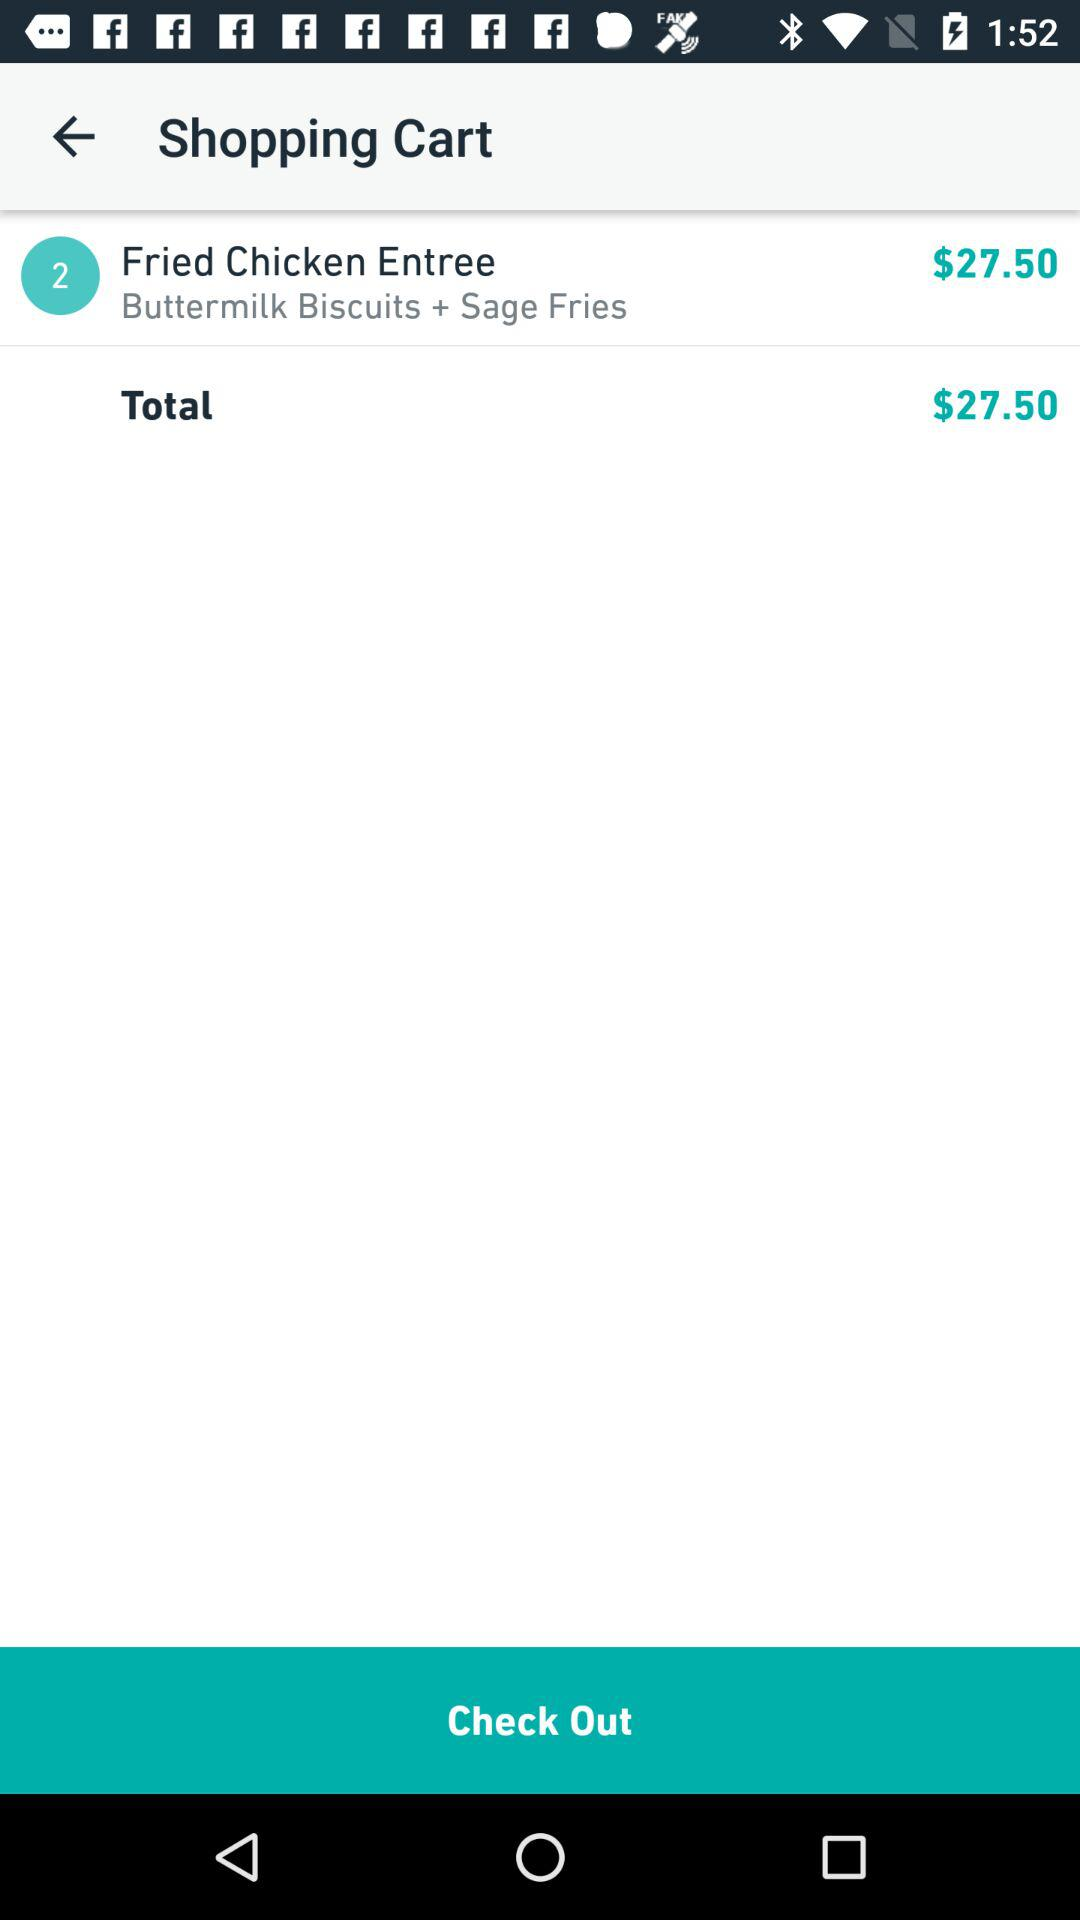How many items are in my cart?
Answer the question using a single word or phrase. 2 